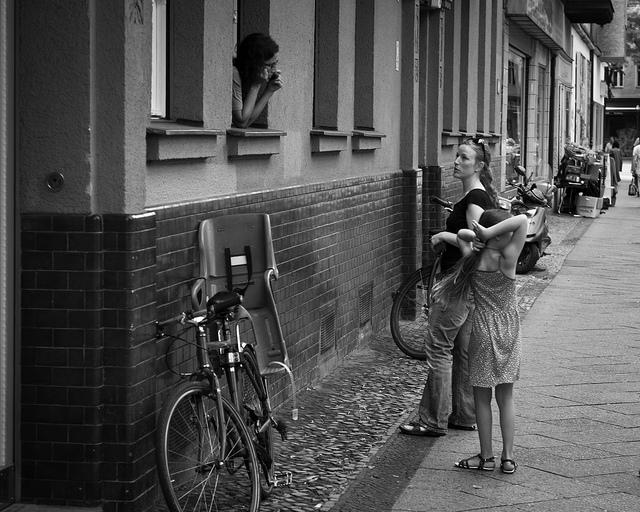The owner of the nearest Bicycle here has which role? Please explain your reasoning. parent. The closest bicycle has a child seat attached so that makes it obvious that it's a bike ridden by a parent. 